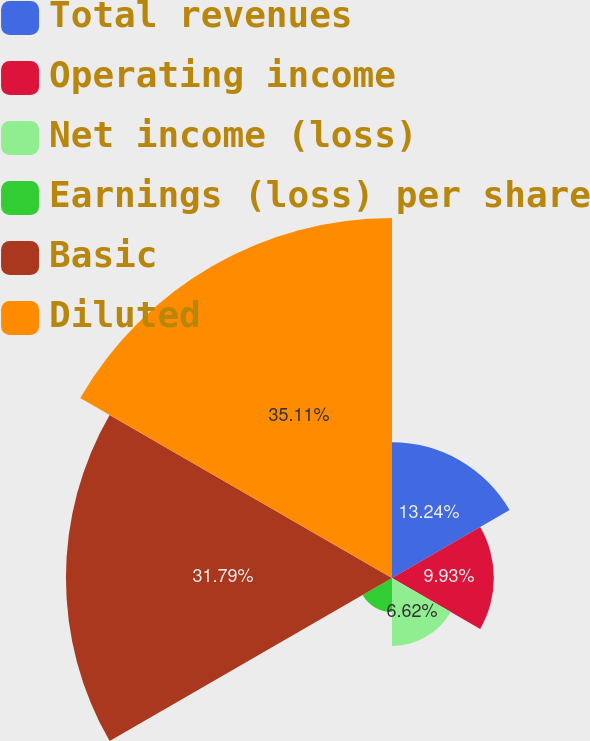Convert chart to OTSL. <chart><loc_0><loc_0><loc_500><loc_500><pie_chart><fcel>Total revenues<fcel>Operating income<fcel>Net income (loss)<fcel>Earnings (loss) per share<fcel>Basic<fcel>Diluted<nl><fcel>13.24%<fcel>9.93%<fcel>6.62%<fcel>3.31%<fcel>31.79%<fcel>35.1%<nl></chart> 